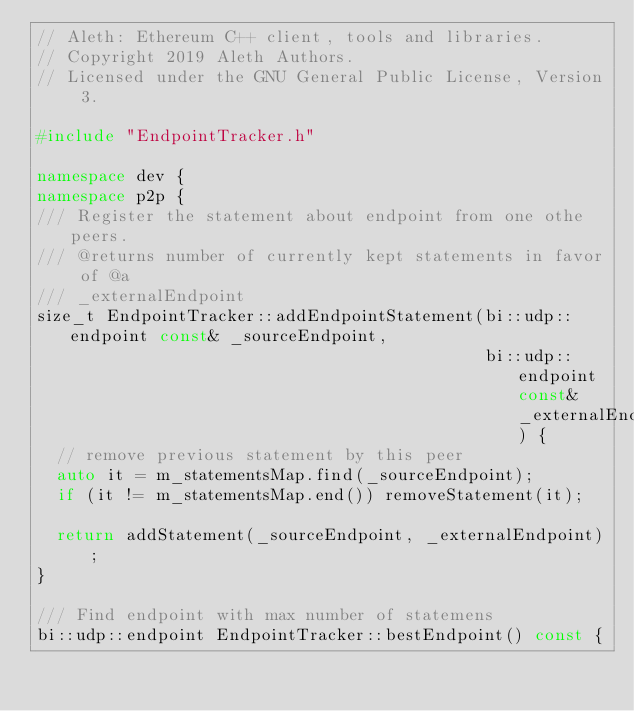Convert code to text. <code><loc_0><loc_0><loc_500><loc_500><_C++_>// Aleth: Ethereum C++ client, tools and libraries.
// Copyright 2019 Aleth Authors.
// Licensed under the GNU General Public License, Version 3.

#include "EndpointTracker.h"

namespace dev {
namespace p2p {
/// Register the statement about endpoint from one othe peers.
/// @returns number of currently kept statements in favor of @a
/// _externalEndpoint
size_t EndpointTracker::addEndpointStatement(bi::udp::endpoint const& _sourceEndpoint,
                                             bi::udp::endpoint const& _externalEndpoint) {
  // remove previous statement by this peer
  auto it = m_statementsMap.find(_sourceEndpoint);
  if (it != m_statementsMap.end()) removeStatement(it);

  return addStatement(_sourceEndpoint, _externalEndpoint);
}

/// Find endpoint with max number of statemens
bi::udp::endpoint EndpointTracker::bestEndpoint() const {</code> 